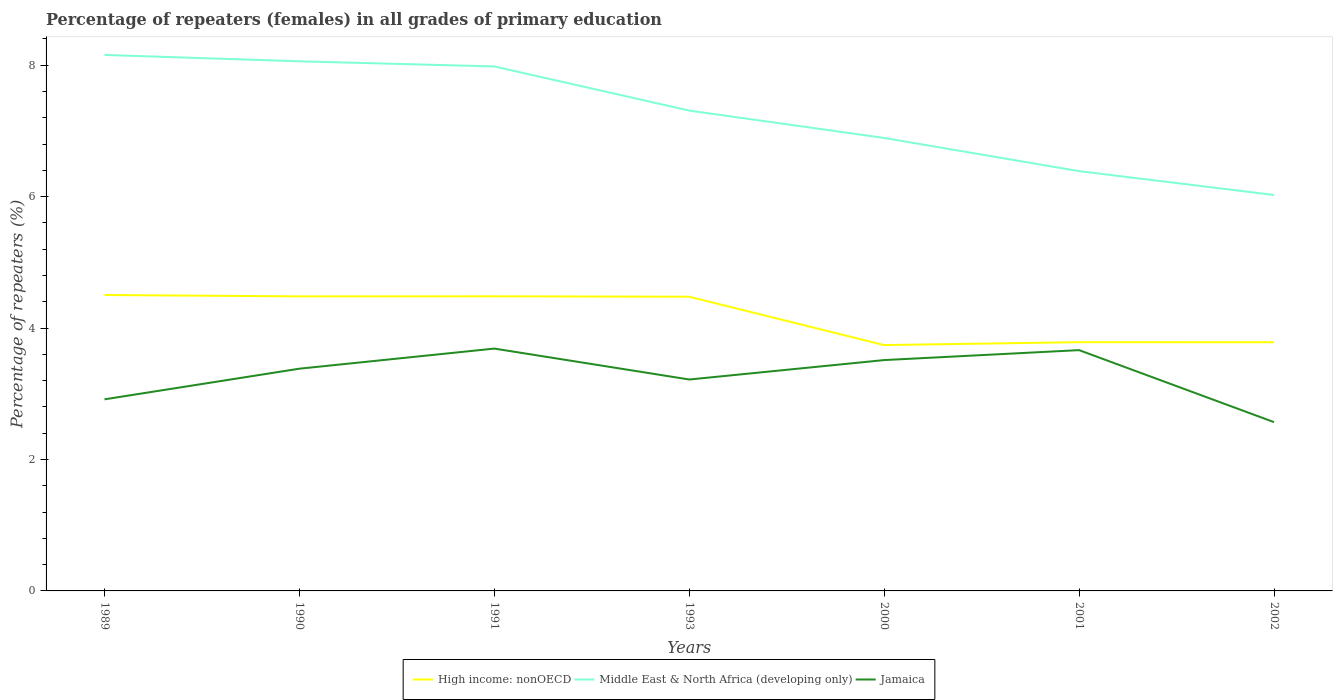How many different coloured lines are there?
Your answer should be compact. 3. Across all years, what is the maximum percentage of repeaters (females) in High income: nonOECD?
Offer a terse response. 3.74. What is the total percentage of repeaters (females) in High income: nonOECD in the graph?
Keep it short and to the point. 0.72. What is the difference between the highest and the second highest percentage of repeaters (females) in High income: nonOECD?
Offer a very short reply. 0.76. What is the difference between the highest and the lowest percentage of repeaters (females) in Jamaica?
Ensure brevity in your answer.  4. How many lines are there?
Give a very brief answer. 3. Where does the legend appear in the graph?
Offer a very short reply. Bottom center. How many legend labels are there?
Your answer should be very brief. 3. What is the title of the graph?
Give a very brief answer. Percentage of repeaters (females) in all grades of primary education. Does "Panama" appear as one of the legend labels in the graph?
Provide a short and direct response. No. What is the label or title of the Y-axis?
Offer a terse response. Percentage of repeaters (%). What is the Percentage of repeaters (%) in High income: nonOECD in 1989?
Make the answer very short. 4.5. What is the Percentage of repeaters (%) of Middle East & North Africa (developing only) in 1989?
Your response must be concise. 8.16. What is the Percentage of repeaters (%) in Jamaica in 1989?
Give a very brief answer. 2.92. What is the Percentage of repeaters (%) of High income: nonOECD in 1990?
Your answer should be compact. 4.48. What is the Percentage of repeaters (%) of Middle East & North Africa (developing only) in 1990?
Offer a very short reply. 8.06. What is the Percentage of repeaters (%) of Jamaica in 1990?
Keep it short and to the point. 3.38. What is the Percentage of repeaters (%) of High income: nonOECD in 1991?
Your answer should be very brief. 4.48. What is the Percentage of repeaters (%) of Middle East & North Africa (developing only) in 1991?
Provide a short and direct response. 7.98. What is the Percentage of repeaters (%) in Jamaica in 1991?
Your answer should be very brief. 3.69. What is the Percentage of repeaters (%) of High income: nonOECD in 1993?
Offer a very short reply. 4.48. What is the Percentage of repeaters (%) in Middle East & North Africa (developing only) in 1993?
Provide a short and direct response. 7.31. What is the Percentage of repeaters (%) in Jamaica in 1993?
Your answer should be compact. 3.22. What is the Percentage of repeaters (%) of High income: nonOECD in 2000?
Your answer should be compact. 3.74. What is the Percentage of repeaters (%) in Middle East & North Africa (developing only) in 2000?
Make the answer very short. 6.89. What is the Percentage of repeaters (%) of Jamaica in 2000?
Your answer should be compact. 3.51. What is the Percentage of repeaters (%) in High income: nonOECD in 2001?
Keep it short and to the point. 3.78. What is the Percentage of repeaters (%) in Middle East & North Africa (developing only) in 2001?
Your response must be concise. 6.39. What is the Percentage of repeaters (%) in Jamaica in 2001?
Make the answer very short. 3.66. What is the Percentage of repeaters (%) in High income: nonOECD in 2002?
Give a very brief answer. 3.78. What is the Percentage of repeaters (%) of Middle East & North Africa (developing only) in 2002?
Provide a succinct answer. 6.02. What is the Percentage of repeaters (%) in Jamaica in 2002?
Provide a succinct answer. 2.57. Across all years, what is the maximum Percentage of repeaters (%) of High income: nonOECD?
Your answer should be compact. 4.5. Across all years, what is the maximum Percentage of repeaters (%) in Middle East & North Africa (developing only)?
Provide a short and direct response. 8.16. Across all years, what is the maximum Percentage of repeaters (%) in Jamaica?
Offer a terse response. 3.69. Across all years, what is the minimum Percentage of repeaters (%) in High income: nonOECD?
Offer a terse response. 3.74. Across all years, what is the minimum Percentage of repeaters (%) in Middle East & North Africa (developing only)?
Give a very brief answer. 6.02. Across all years, what is the minimum Percentage of repeaters (%) of Jamaica?
Offer a terse response. 2.57. What is the total Percentage of repeaters (%) of High income: nonOECD in the graph?
Make the answer very short. 29.25. What is the total Percentage of repeaters (%) in Middle East & North Africa (developing only) in the graph?
Provide a short and direct response. 50.81. What is the total Percentage of repeaters (%) of Jamaica in the graph?
Your answer should be very brief. 22.95. What is the difference between the Percentage of repeaters (%) in High income: nonOECD in 1989 and that in 1990?
Offer a very short reply. 0.02. What is the difference between the Percentage of repeaters (%) of Middle East & North Africa (developing only) in 1989 and that in 1990?
Give a very brief answer. 0.1. What is the difference between the Percentage of repeaters (%) in Jamaica in 1989 and that in 1990?
Your answer should be very brief. -0.47. What is the difference between the Percentage of repeaters (%) in High income: nonOECD in 1989 and that in 1991?
Make the answer very short. 0.02. What is the difference between the Percentage of repeaters (%) in Middle East & North Africa (developing only) in 1989 and that in 1991?
Offer a terse response. 0.17. What is the difference between the Percentage of repeaters (%) of Jamaica in 1989 and that in 1991?
Offer a very short reply. -0.77. What is the difference between the Percentage of repeaters (%) of High income: nonOECD in 1989 and that in 1993?
Offer a terse response. 0.03. What is the difference between the Percentage of repeaters (%) in Middle East & North Africa (developing only) in 1989 and that in 1993?
Offer a terse response. 0.85. What is the difference between the Percentage of repeaters (%) in Jamaica in 1989 and that in 1993?
Provide a short and direct response. -0.3. What is the difference between the Percentage of repeaters (%) in High income: nonOECD in 1989 and that in 2000?
Provide a succinct answer. 0.76. What is the difference between the Percentage of repeaters (%) in Middle East & North Africa (developing only) in 1989 and that in 2000?
Give a very brief answer. 1.26. What is the difference between the Percentage of repeaters (%) of Jamaica in 1989 and that in 2000?
Ensure brevity in your answer.  -0.6. What is the difference between the Percentage of repeaters (%) in High income: nonOECD in 1989 and that in 2001?
Offer a terse response. 0.72. What is the difference between the Percentage of repeaters (%) of Middle East & North Africa (developing only) in 1989 and that in 2001?
Make the answer very short. 1.77. What is the difference between the Percentage of repeaters (%) in Jamaica in 1989 and that in 2001?
Make the answer very short. -0.75. What is the difference between the Percentage of repeaters (%) in High income: nonOECD in 1989 and that in 2002?
Offer a terse response. 0.72. What is the difference between the Percentage of repeaters (%) in Middle East & North Africa (developing only) in 1989 and that in 2002?
Make the answer very short. 2.13. What is the difference between the Percentage of repeaters (%) in Jamaica in 1989 and that in 2002?
Your answer should be very brief. 0.35. What is the difference between the Percentage of repeaters (%) of High income: nonOECD in 1990 and that in 1991?
Keep it short and to the point. -0. What is the difference between the Percentage of repeaters (%) in Middle East & North Africa (developing only) in 1990 and that in 1991?
Ensure brevity in your answer.  0.08. What is the difference between the Percentage of repeaters (%) in Jamaica in 1990 and that in 1991?
Your answer should be very brief. -0.31. What is the difference between the Percentage of repeaters (%) in High income: nonOECD in 1990 and that in 1993?
Your answer should be very brief. 0.01. What is the difference between the Percentage of repeaters (%) in Middle East & North Africa (developing only) in 1990 and that in 1993?
Give a very brief answer. 0.75. What is the difference between the Percentage of repeaters (%) of Jamaica in 1990 and that in 1993?
Your answer should be very brief. 0.16. What is the difference between the Percentage of repeaters (%) of High income: nonOECD in 1990 and that in 2000?
Your answer should be very brief. 0.74. What is the difference between the Percentage of repeaters (%) in Middle East & North Africa (developing only) in 1990 and that in 2000?
Your response must be concise. 1.17. What is the difference between the Percentage of repeaters (%) of Jamaica in 1990 and that in 2000?
Offer a terse response. -0.13. What is the difference between the Percentage of repeaters (%) of High income: nonOECD in 1990 and that in 2001?
Offer a terse response. 0.7. What is the difference between the Percentage of repeaters (%) in Middle East & North Africa (developing only) in 1990 and that in 2001?
Ensure brevity in your answer.  1.67. What is the difference between the Percentage of repeaters (%) of Jamaica in 1990 and that in 2001?
Ensure brevity in your answer.  -0.28. What is the difference between the Percentage of repeaters (%) of High income: nonOECD in 1990 and that in 2002?
Make the answer very short. 0.7. What is the difference between the Percentage of repeaters (%) in Middle East & North Africa (developing only) in 1990 and that in 2002?
Keep it short and to the point. 2.03. What is the difference between the Percentage of repeaters (%) of Jamaica in 1990 and that in 2002?
Offer a very short reply. 0.81. What is the difference between the Percentage of repeaters (%) in High income: nonOECD in 1991 and that in 1993?
Provide a succinct answer. 0.01. What is the difference between the Percentage of repeaters (%) of Middle East & North Africa (developing only) in 1991 and that in 1993?
Offer a terse response. 0.67. What is the difference between the Percentage of repeaters (%) in Jamaica in 1991 and that in 1993?
Offer a terse response. 0.47. What is the difference between the Percentage of repeaters (%) in High income: nonOECD in 1991 and that in 2000?
Ensure brevity in your answer.  0.74. What is the difference between the Percentage of repeaters (%) in Middle East & North Africa (developing only) in 1991 and that in 2000?
Provide a short and direct response. 1.09. What is the difference between the Percentage of repeaters (%) in Jamaica in 1991 and that in 2000?
Provide a short and direct response. 0.17. What is the difference between the Percentage of repeaters (%) of High income: nonOECD in 1991 and that in 2001?
Your response must be concise. 0.7. What is the difference between the Percentage of repeaters (%) in Middle East & North Africa (developing only) in 1991 and that in 2001?
Keep it short and to the point. 1.59. What is the difference between the Percentage of repeaters (%) in Jamaica in 1991 and that in 2001?
Provide a succinct answer. 0.02. What is the difference between the Percentage of repeaters (%) of High income: nonOECD in 1991 and that in 2002?
Keep it short and to the point. 0.7. What is the difference between the Percentage of repeaters (%) in Middle East & North Africa (developing only) in 1991 and that in 2002?
Your answer should be very brief. 1.96. What is the difference between the Percentage of repeaters (%) in Jamaica in 1991 and that in 2002?
Your answer should be very brief. 1.12. What is the difference between the Percentage of repeaters (%) in High income: nonOECD in 1993 and that in 2000?
Your response must be concise. 0.74. What is the difference between the Percentage of repeaters (%) in Middle East & North Africa (developing only) in 1993 and that in 2000?
Provide a succinct answer. 0.42. What is the difference between the Percentage of repeaters (%) of Jamaica in 1993 and that in 2000?
Provide a succinct answer. -0.3. What is the difference between the Percentage of repeaters (%) in High income: nonOECD in 1993 and that in 2001?
Make the answer very short. 0.69. What is the difference between the Percentage of repeaters (%) of Middle East & North Africa (developing only) in 1993 and that in 2001?
Give a very brief answer. 0.92. What is the difference between the Percentage of repeaters (%) of Jamaica in 1993 and that in 2001?
Provide a short and direct response. -0.45. What is the difference between the Percentage of repeaters (%) in High income: nonOECD in 1993 and that in 2002?
Provide a short and direct response. 0.69. What is the difference between the Percentage of repeaters (%) of Middle East & North Africa (developing only) in 1993 and that in 2002?
Keep it short and to the point. 1.28. What is the difference between the Percentage of repeaters (%) of Jamaica in 1993 and that in 2002?
Keep it short and to the point. 0.65. What is the difference between the Percentage of repeaters (%) of High income: nonOECD in 2000 and that in 2001?
Your answer should be very brief. -0.04. What is the difference between the Percentage of repeaters (%) in Middle East & North Africa (developing only) in 2000 and that in 2001?
Give a very brief answer. 0.51. What is the difference between the Percentage of repeaters (%) of Jamaica in 2000 and that in 2001?
Ensure brevity in your answer.  -0.15. What is the difference between the Percentage of repeaters (%) in High income: nonOECD in 2000 and that in 2002?
Keep it short and to the point. -0.04. What is the difference between the Percentage of repeaters (%) of Middle East & North Africa (developing only) in 2000 and that in 2002?
Provide a succinct answer. 0.87. What is the difference between the Percentage of repeaters (%) of Jamaica in 2000 and that in 2002?
Make the answer very short. 0.94. What is the difference between the Percentage of repeaters (%) of High income: nonOECD in 2001 and that in 2002?
Provide a succinct answer. 0. What is the difference between the Percentage of repeaters (%) of Middle East & North Africa (developing only) in 2001 and that in 2002?
Provide a short and direct response. 0.36. What is the difference between the Percentage of repeaters (%) in Jamaica in 2001 and that in 2002?
Keep it short and to the point. 1.1. What is the difference between the Percentage of repeaters (%) of High income: nonOECD in 1989 and the Percentage of repeaters (%) of Middle East & North Africa (developing only) in 1990?
Make the answer very short. -3.56. What is the difference between the Percentage of repeaters (%) in High income: nonOECD in 1989 and the Percentage of repeaters (%) in Jamaica in 1990?
Offer a terse response. 1.12. What is the difference between the Percentage of repeaters (%) of Middle East & North Africa (developing only) in 1989 and the Percentage of repeaters (%) of Jamaica in 1990?
Make the answer very short. 4.77. What is the difference between the Percentage of repeaters (%) in High income: nonOECD in 1989 and the Percentage of repeaters (%) in Middle East & North Africa (developing only) in 1991?
Your response must be concise. -3.48. What is the difference between the Percentage of repeaters (%) in High income: nonOECD in 1989 and the Percentage of repeaters (%) in Jamaica in 1991?
Your answer should be very brief. 0.82. What is the difference between the Percentage of repeaters (%) in Middle East & North Africa (developing only) in 1989 and the Percentage of repeaters (%) in Jamaica in 1991?
Your answer should be compact. 4.47. What is the difference between the Percentage of repeaters (%) of High income: nonOECD in 1989 and the Percentage of repeaters (%) of Middle East & North Africa (developing only) in 1993?
Your answer should be very brief. -2.81. What is the difference between the Percentage of repeaters (%) of High income: nonOECD in 1989 and the Percentage of repeaters (%) of Jamaica in 1993?
Your answer should be compact. 1.29. What is the difference between the Percentage of repeaters (%) in Middle East & North Africa (developing only) in 1989 and the Percentage of repeaters (%) in Jamaica in 1993?
Your answer should be very brief. 4.94. What is the difference between the Percentage of repeaters (%) in High income: nonOECD in 1989 and the Percentage of repeaters (%) in Middle East & North Africa (developing only) in 2000?
Ensure brevity in your answer.  -2.39. What is the difference between the Percentage of repeaters (%) of High income: nonOECD in 1989 and the Percentage of repeaters (%) of Jamaica in 2000?
Ensure brevity in your answer.  0.99. What is the difference between the Percentage of repeaters (%) of Middle East & North Africa (developing only) in 1989 and the Percentage of repeaters (%) of Jamaica in 2000?
Provide a succinct answer. 4.64. What is the difference between the Percentage of repeaters (%) of High income: nonOECD in 1989 and the Percentage of repeaters (%) of Middle East & North Africa (developing only) in 2001?
Keep it short and to the point. -1.88. What is the difference between the Percentage of repeaters (%) of High income: nonOECD in 1989 and the Percentage of repeaters (%) of Jamaica in 2001?
Ensure brevity in your answer.  0.84. What is the difference between the Percentage of repeaters (%) of Middle East & North Africa (developing only) in 1989 and the Percentage of repeaters (%) of Jamaica in 2001?
Provide a short and direct response. 4.49. What is the difference between the Percentage of repeaters (%) of High income: nonOECD in 1989 and the Percentage of repeaters (%) of Middle East & North Africa (developing only) in 2002?
Offer a terse response. -1.52. What is the difference between the Percentage of repeaters (%) of High income: nonOECD in 1989 and the Percentage of repeaters (%) of Jamaica in 2002?
Offer a terse response. 1.93. What is the difference between the Percentage of repeaters (%) of Middle East & North Africa (developing only) in 1989 and the Percentage of repeaters (%) of Jamaica in 2002?
Provide a succinct answer. 5.59. What is the difference between the Percentage of repeaters (%) of High income: nonOECD in 1990 and the Percentage of repeaters (%) of Middle East & North Africa (developing only) in 1991?
Make the answer very short. -3.5. What is the difference between the Percentage of repeaters (%) in High income: nonOECD in 1990 and the Percentage of repeaters (%) in Jamaica in 1991?
Provide a succinct answer. 0.79. What is the difference between the Percentage of repeaters (%) in Middle East & North Africa (developing only) in 1990 and the Percentage of repeaters (%) in Jamaica in 1991?
Ensure brevity in your answer.  4.37. What is the difference between the Percentage of repeaters (%) in High income: nonOECD in 1990 and the Percentage of repeaters (%) in Middle East & North Africa (developing only) in 1993?
Your answer should be very brief. -2.83. What is the difference between the Percentage of repeaters (%) in High income: nonOECD in 1990 and the Percentage of repeaters (%) in Jamaica in 1993?
Give a very brief answer. 1.26. What is the difference between the Percentage of repeaters (%) in Middle East & North Africa (developing only) in 1990 and the Percentage of repeaters (%) in Jamaica in 1993?
Provide a short and direct response. 4.84. What is the difference between the Percentage of repeaters (%) in High income: nonOECD in 1990 and the Percentage of repeaters (%) in Middle East & North Africa (developing only) in 2000?
Provide a short and direct response. -2.41. What is the difference between the Percentage of repeaters (%) of High income: nonOECD in 1990 and the Percentage of repeaters (%) of Jamaica in 2000?
Your answer should be compact. 0.97. What is the difference between the Percentage of repeaters (%) of Middle East & North Africa (developing only) in 1990 and the Percentage of repeaters (%) of Jamaica in 2000?
Make the answer very short. 4.55. What is the difference between the Percentage of repeaters (%) in High income: nonOECD in 1990 and the Percentage of repeaters (%) in Middle East & North Africa (developing only) in 2001?
Make the answer very short. -1.91. What is the difference between the Percentage of repeaters (%) in High income: nonOECD in 1990 and the Percentage of repeaters (%) in Jamaica in 2001?
Your answer should be compact. 0.82. What is the difference between the Percentage of repeaters (%) in Middle East & North Africa (developing only) in 1990 and the Percentage of repeaters (%) in Jamaica in 2001?
Your answer should be compact. 4.39. What is the difference between the Percentage of repeaters (%) in High income: nonOECD in 1990 and the Percentage of repeaters (%) in Middle East & North Africa (developing only) in 2002?
Provide a short and direct response. -1.54. What is the difference between the Percentage of repeaters (%) of High income: nonOECD in 1990 and the Percentage of repeaters (%) of Jamaica in 2002?
Ensure brevity in your answer.  1.91. What is the difference between the Percentage of repeaters (%) in Middle East & North Africa (developing only) in 1990 and the Percentage of repeaters (%) in Jamaica in 2002?
Keep it short and to the point. 5.49. What is the difference between the Percentage of repeaters (%) of High income: nonOECD in 1991 and the Percentage of repeaters (%) of Middle East & North Africa (developing only) in 1993?
Your answer should be very brief. -2.83. What is the difference between the Percentage of repeaters (%) in High income: nonOECD in 1991 and the Percentage of repeaters (%) in Jamaica in 1993?
Provide a succinct answer. 1.27. What is the difference between the Percentage of repeaters (%) of Middle East & North Africa (developing only) in 1991 and the Percentage of repeaters (%) of Jamaica in 1993?
Your response must be concise. 4.76. What is the difference between the Percentage of repeaters (%) of High income: nonOECD in 1991 and the Percentage of repeaters (%) of Middle East & North Africa (developing only) in 2000?
Provide a short and direct response. -2.41. What is the difference between the Percentage of repeaters (%) in High income: nonOECD in 1991 and the Percentage of repeaters (%) in Jamaica in 2000?
Your answer should be very brief. 0.97. What is the difference between the Percentage of repeaters (%) in Middle East & North Africa (developing only) in 1991 and the Percentage of repeaters (%) in Jamaica in 2000?
Your answer should be very brief. 4.47. What is the difference between the Percentage of repeaters (%) in High income: nonOECD in 1991 and the Percentage of repeaters (%) in Middle East & North Africa (developing only) in 2001?
Provide a short and direct response. -1.9. What is the difference between the Percentage of repeaters (%) in High income: nonOECD in 1991 and the Percentage of repeaters (%) in Jamaica in 2001?
Give a very brief answer. 0.82. What is the difference between the Percentage of repeaters (%) of Middle East & North Africa (developing only) in 1991 and the Percentage of repeaters (%) of Jamaica in 2001?
Make the answer very short. 4.32. What is the difference between the Percentage of repeaters (%) in High income: nonOECD in 1991 and the Percentage of repeaters (%) in Middle East & North Africa (developing only) in 2002?
Offer a very short reply. -1.54. What is the difference between the Percentage of repeaters (%) of High income: nonOECD in 1991 and the Percentage of repeaters (%) of Jamaica in 2002?
Keep it short and to the point. 1.91. What is the difference between the Percentage of repeaters (%) of Middle East & North Africa (developing only) in 1991 and the Percentage of repeaters (%) of Jamaica in 2002?
Your answer should be compact. 5.41. What is the difference between the Percentage of repeaters (%) of High income: nonOECD in 1993 and the Percentage of repeaters (%) of Middle East & North Africa (developing only) in 2000?
Your answer should be very brief. -2.42. What is the difference between the Percentage of repeaters (%) of High income: nonOECD in 1993 and the Percentage of repeaters (%) of Jamaica in 2000?
Provide a short and direct response. 0.96. What is the difference between the Percentage of repeaters (%) of Middle East & North Africa (developing only) in 1993 and the Percentage of repeaters (%) of Jamaica in 2000?
Ensure brevity in your answer.  3.8. What is the difference between the Percentage of repeaters (%) in High income: nonOECD in 1993 and the Percentage of repeaters (%) in Middle East & North Africa (developing only) in 2001?
Your answer should be very brief. -1.91. What is the difference between the Percentage of repeaters (%) in High income: nonOECD in 1993 and the Percentage of repeaters (%) in Jamaica in 2001?
Provide a succinct answer. 0.81. What is the difference between the Percentage of repeaters (%) of Middle East & North Africa (developing only) in 1993 and the Percentage of repeaters (%) of Jamaica in 2001?
Provide a succinct answer. 3.64. What is the difference between the Percentage of repeaters (%) of High income: nonOECD in 1993 and the Percentage of repeaters (%) of Middle East & North Africa (developing only) in 2002?
Your answer should be compact. -1.55. What is the difference between the Percentage of repeaters (%) in High income: nonOECD in 1993 and the Percentage of repeaters (%) in Jamaica in 2002?
Make the answer very short. 1.91. What is the difference between the Percentage of repeaters (%) of Middle East & North Africa (developing only) in 1993 and the Percentage of repeaters (%) of Jamaica in 2002?
Offer a terse response. 4.74. What is the difference between the Percentage of repeaters (%) in High income: nonOECD in 2000 and the Percentage of repeaters (%) in Middle East & North Africa (developing only) in 2001?
Your response must be concise. -2.65. What is the difference between the Percentage of repeaters (%) of High income: nonOECD in 2000 and the Percentage of repeaters (%) of Jamaica in 2001?
Offer a very short reply. 0.08. What is the difference between the Percentage of repeaters (%) in Middle East & North Africa (developing only) in 2000 and the Percentage of repeaters (%) in Jamaica in 2001?
Ensure brevity in your answer.  3.23. What is the difference between the Percentage of repeaters (%) of High income: nonOECD in 2000 and the Percentage of repeaters (%) of Middle East & North Africa (developing only) in 2002?
Offer a terse response. -2.28. What is the difference between the Percentage of repeaters (%) in High income: nonOECD in 2000 and the Percentage of repeaters (%) in Jamaica in 2002?
Ensure brevity in your answer.  1.17. What is the difference between the Percentage of repeaters (%) of Middle East & North Africa (developing only) in 2000 and the Percentage of repeaters (%) of Jamaica in 2002?
Make the answer very short. 4.32. What is the difference between the Percentage of repeaters (%) of High income: nonOECD in 2001 and the Percentage of repeaters (%) of Middle East & North Africa (developing only) in 2002?
Ensure brevity in your answer.  -2.24. What is the difference between the Percentage of repeaters (%) in High income: nonOECD in 2001 and the Percentage of repeaters (%) in Jamaica in 2002?
Keep it short and to the point. 1.22. What is the difference between the Percentage of repeaters (%) of Middle East & North Africa (developing only) in 2001 and the Percentage of repeaters (%) of Jamaica in 2002?
Your answer should be very brief. 3.82. What is the average Percentage of repeaters (%) of High income: nonOECD per year?
Ensure brevity in your answer.  4.18. What is the average Percentage of repeaters (%) of Middle East & North Africa (developing only) per year?
Your answer should be compact. 7.26. What is the average Percentage of repeaters (%) of Jamaica per year?
Keep it short and to the point. 3.28. In the year 1989, what is the difference between the Percentage of repeaters (%) of High income: nonOECD and Percentage of repeaters (%) of Middle East & North Africa (developing only)?
Your answer should be very brief. -3.65. In the year 1989, what is the difference between the Percentage of repeaters (%) in High income: nonOECD and Percentage of repeaters (%) in Jamaica?
Give a very brief answer. 1.59. In the year 1989, what is the difference between the Percentage of repeaters (%) in Middle East & North Africa (developing only) and Percentage of repeaters (%) in Jamaica?
Provide a succinct answer. 5.24. In the year 1990, what is the difference between the Percentage of repeaters (%) of High income: nonOECD and Percentage of repeaters (%) of Middle East & North Africa (developing only)?
Give a very brief answer. -3.58. In the year 1990, what is the difference between the Percentage of repeaters (%) in High income: nonOECD and Percentage of repeaters (%) in Jamaica?
Keep it short and to the point. 1.1. In the year 1990, what is the difference between the Percentage of repeaters (%) of Middle East & North Africa (developing only) and Percentage of repeaters (%) of Jamaica?
Provide a short and direct response. 4.68. In the year 1991, what is the difference between the Percentage of repeaters (%) of High income: nonOECD and Percentage of repeaters (%) of Middle East & North Africa (developing only)?
Offer a very short reply. -3.5. In the year 1991, what is the difference between the Percentage of repeaters (%) of High income: nonOECD and Percentage of repeaters (%) of Jamaica?
Provide a succinct answer. 0.8. In the year 1991, what is the difference between the Percentage of repeaters (%) of Middle East & North Africa (developing only) and Percentage of repeaters (%) of Jamaica?
Offer a terse response. 4.29. In the year 1993, what is the difference between the Percentage of repeaters (%) of High income: nonOECD and Percentage of repeaters (%) of Middle East & North Africa (developing only)?
Ensure brevity in your answer.  -2.83. In the year 1993, what is the difference between the Percentage of repeaters (%) of High income: nonOECD and Percentage of repeaters (%) of Jamaica?
Give a very brief answer. 1.26. In the year 1993, what is the difference between the Percentage of repeaters (%) of Middle East & North Africa (developing only) and Percentage of repeaters (%) of Jamaica?
Your answer should be very brief. 4.09. In the year 2000, what is the difference between the Percentage of repeaters (%) of High income: nonOECD and Percentage of repeaters (%) of Middle East & North Africa (developing only)?
Give a very brief answer. -3.15. In the year 2000, what is the difference between the Percentage of repeaters (%) of High income: nonOECD and Percentage of repeaters (%) of Jamaica?
Give a very brief answer. 0.23. In the year 2000, what is the difference between the Percentage of repeaters (%) of Middle East & North Africa (developing only) and Percentage of repeaters (%) of Jamaica?
Ensure brevity in your answer.  3.38. In the year 2001, what is the difference between the Percentage of repeaters (%) of High income: nonOECD and Percentage of repeaters (%) of Middle East & North Africa (developing only)?
Offer a very short reply. -2.6. In the year 2001, what is the difference between the Percentage of repeaters (%) in High income: nonOECD and Percentage of repeaters (%) in Jamaica?
Your response must be concise. 0.12. In the year 2001, what is the difference between the Percentage of repeaters (%) in Middle East & North Africa (developing only) and Percentage of repeaters (%) in Jamaica?
Keep it short and to the point. 2.72. In the year 2002, what is the difference between the Percentage of repeaters (%) in High income: nonOECD and Percentage of repeaters (%) in Middle East & North Africa (developing only)?
Give a very brief answer. -2.24. In the year 2002, what is the difference between the Percentage of repeaters (%) of High income: nonOECD and Percentage of repeaters (%) of Jamaica?
Give a very brief answer. 1.22. In the year 2002, what is the difference between the Percentage of repeaters (%) in Middle East & North Africa (developing only) and Percentage of repeaters (%) in Jamaica?
Your answer should be compact. 3.46. What is the ratio of the Percentage of repeaters (%) of Middle East & North Africa (developing only) in 1989 to that in 1990?
Give a very brief answer. 1.01. What is the ratio of the Percentage of repeaters (%) of Jamaica in 1989 to that in 1990?
Your answer should be very brief. 0.86. What is the ratio of the Percentage of repeaters (%) of Middle East & North Africa (developing only) in 1989 to that in 1991?
Ensure brevity in your answer.  1.02. What is the ratio of the Percentage of repeaters (%) in Jamaica in 1989 to that in 1991?
Provide a succinct answer. 0.79. What is the ratio of the Percentage of repeaters (%) of Middle East & North Africa (developing only) in 1989 to that in 1993?
Your response must be concise. 1.12. What is the ratio of the Percentage of repeaters (%) in Jamaica in 1989 to that in 1993?
Ensure brevity in your answer.  0.91. What is the ratio of the Percentage of repeaters (%) of High income: nonOECD in 1989 to that in 2000?
Provide a succinct answer. 1.2. What is the ratio of the Percentage of repeaters (%) in Middle East & North Africa (developing only) in 1989 to that in 2000?
Your response must be concise. 1.18. What is the ratio of the Percentage of repeaters (%) of Jamaica in 1989 to that in 2000?
Your answer should be compact. 0.83. What is the ratio of the Percentage of repeaters (%) of High income: nonOECD in 1989 to that in 2001?
Provide a succinct answer. 1.19. What is the ratio of the Percentage of repeaters (%) in Middle East & North Africa (developing only) in 1989 to that in 2001?
Make the answer very short. 1.28. What is the ratio of the Percentage of repeaters (%) in Jamaica in 1989 to that in 2001?
Give a very brief answer. 0.8. What is the ratio of the Percentage of repeaters (%) of High income: nonOECD in 1989 to that in 2002?
Provide a short and direct response. 1.19. What is the ratio of the Percentage of repeaters (%) in Middle East & North Africa (developing only) in 1989 to that in 2002?
Your answer should be compact. 1.35. What is the ratio of the Percentage of repeaters (%) in Jamaica in 1989 to that in 2002?
Provide a short and direct response. 1.14. What is the ratio of the Percentage of repeaters (%) in High income: nonOECD in 1990 to that in 1991?
Provide a succinct answer. 1. What is the ratio of the Percentage of repeaters (%) in Middle East & North Africa (developing only) in 1990 to that in 1991?
Provide a short and direct response. 1.01. What is the ratio of the Percentage of repeaters (%) in Jamaica in 1990 to that in 1991?
Your answer should be compact. 0.92. What is the ratio of the Percentage of repeaters (%) of High income: nonOECD in 1990 to that in 1993?
Your answer should be compact. 1. What is the ratio of the Percentage of repeaters (%) in Middle East & North Africa (developing only) in 1990 to that in 1993?
Give a very brief answer. 1.1. What is the ratio of the Percentage of repeaters (%) of Jamaica in 1990 to that in 1993?
Provide a short and direct response. 1.05. What is the ratio of the Percentage of repeaters (%) of High income: nonOECD in 1990 to that in 2000?
Your response must be concise. 1.2. What is the ratio of the Percentage of repeaters (%) in Middle East & North Africa (developing only) in 1990 to that in 2000?
Your answer should be very brief. 1.17. What is the ratio of the Percentage of repeaters (%) of Jamaica in 1990 to that in 2000?
Your answer should be compact. 0.96. What is the ratio of the Percentage of repeaters (%) in High income: nonOECD in 1990 to that in 2001?
Ensure brevity in your answer.  1.18. What is the ratio of the Percentage of repeaters (%) in Middle East & North Africa (developing only) in 1990 to that in 2001?
Keep it short and to the point. 1.26. What is the ratio of the Percentage of repeaters (%) of Jamaica in 1990 to that in 2001?
Give a very brief answer. 0.92. What is the ratio of the Percentage of repeaters (%) in High income: nonOECD in 1990 to that in 2002?
Ensure brevity in your answer.  1.18. What is the ratio of the Percentage of repeaters (%) of Middle East & North Africa (developing only) in 1990 to that in 2002?
Keep it short and to the point. 1.34. What is the ratio of the Percentage of repeaters (%) of Jamaica in 1990 to that in 2002?
Make the answer very short. 1.32. What is the ratio of the Percentage of repeaters (%) of High income: nonOECD in 1991 to that in 1993?
Your response must be concise. 1. What is the ratio of the Percentage of repeaters (%) of Middle East & North Africa (developing only) in 1991 to that in 1993?
Your answer should be very brief. 1.09. What is the ratio of the Percentage of repeaters (%) in Jamaica in 1991 to that in 1993?
Your answer should be very brief. 1.15. What is the ratio of the Percentage of repeaters (%) in High income: nonOECD in 1991 to that in 2000?
Offer a very short reply. 1.2. What is the ratio of the Percentage of repeaters (%) in Middle East & North Africa (developing only) in 1991 to that in 2000?
Provide a succinct answer. 1.16. What is the ratio of the Percentage of repeaters (%) of Jamaica in 1991 to that in 2000?
Your answer should be very brief. 1.05. What is the ratio of the Percentage of repeaters (%) in High income: nonOECD in 1991 to that in 2001?
Give a very brief answer. 1.18. What is the ratio of the Percentage of repeaters (%) of Middle East & North Africa (developing only) in 1991 to that in 2001?
Your response must be concise. 1.25. What is the ratio of the Percentage of repeaters (%) of Jamaica in 1991 to that in 2001?
Ensure brevity in your answer.  1.01. What is the ratio of the Percentage of repeaters (%) in High income: nonOECD in 1991 to that in 2002?
Keep it short and to the point. 1.18. What is the ratio of the Percentage of repeaters (%) of Middle East & North Africa (developing only) in 1991 to that in 2002?
Your response must be concise. 1.32. What is the ratio of the Percentage of repeaters (%) of Jamaica in 1991 to that in 2002?
Your response must be concise. 1.44. What is the ratio of the Percentage of repeaters (%) in High income: nonOECD in 1993 to that in 2000?
Ensure brevity in your answer.  1.2. What is the ratio of the Percentage of repeaters (%) of Middle East & North Africa (developing only) in 1993 to that in 2000?
Provide a succinct answer. 1.06. What is the ratio of the Percentage of repeaters (%) of Jamaica in 1993 to that in 2000?
Your response must be concise. 0.92. What is the ratio of the Percentage of repeaters (%) in High income: nonOECD in 1993 to that in 2001?
Provide a succinct answer. 1.18. What is the ratio of the Percentage of repeaters (%) of Middle East & North Africa (developing only) in 1993 to that in 2001?
Give a very brief answer. 1.14. What is the ratio of the Percentage of repeaters (%) in Jamaica in 1993 to that in 2001?
Provide a succinct answer. 0.88. What is the ratio of the Percentage of repeaters (%) of High income: nonOECD in 1993 to that in 2002?
Make the answer very short. 1.18. What is the ratio of the Percentage of repeaters (%) of Middle East & North Africa (developing only) in 1993 to that in 2002?
Offer a very short reply. 1.21. What is the ratio of the Percentage of repeaters (%) of Jamaica in 1993 to that in 2002?
Your answer should be very brief. 1.25. What is the ratio of the Percentage of repeaters (%) of High income: nonOECD in 2000 to that in 2001?
Make the answer very short. 0.99. What is the ratio of the Percentage of repeaters (%) of Middle East & North Africa (developing only) in 2000 to that in 2001?
Keep it short and to the point. 1.08. What is the ratio of the Percentage of repeaters (%) in Jamaica in 2000 to that in 2001?
Provide a succinct answer. 0.96. What is the ratio of the Percentage of repeaters (%) in Middle East & North Africa (developing only) in 2000 to that in 2002?
Make the answer very short. 1.14. What is the ratio of the Percentage of repeaters (%) in Jamaica in 2000 to that in 2002?
Give a very brief answer. 1.37. What is the ratio of the Percentage of repeaters (%) of Middle East & North Africa (developing only) in 2001 to that in 2002?
Ensure brevity in your answer.  1.06. What is the ratio of the Percentage of repeaters (%) in Jamaica in 2001 to that in 2002?
Provide a short and direct response. 1.43. What is the difference between the highest and the second highest Percentage of repeaters (%) in High income: nonOECD?
Your response must be concise. 0.02. What is the difference between the highest and the second highest Percentage of repeaters (%) of Middle East & North Africa (developing only)?
Ensure brevity in your answer.  0.1. What is the difference between the highest and the second highest Percentage of repeaters (%) of Jamaica?
Ensure brevity in your answer.  0.02. What is the difference between the highest and the lowest Percentage of repeaters (%) of High income: nonOECD?
Your answer should be compact. 0.76. What is the difference between the highest and the lowest Percentage of repeaters (%) in Middle East & North Africa (developing only)?
Provide a short and direct response. 2.13. What is the difference between the highest and the lowest Percentage of repeaters (%) of Jamaica?
Make the answer very short. 1.12. 